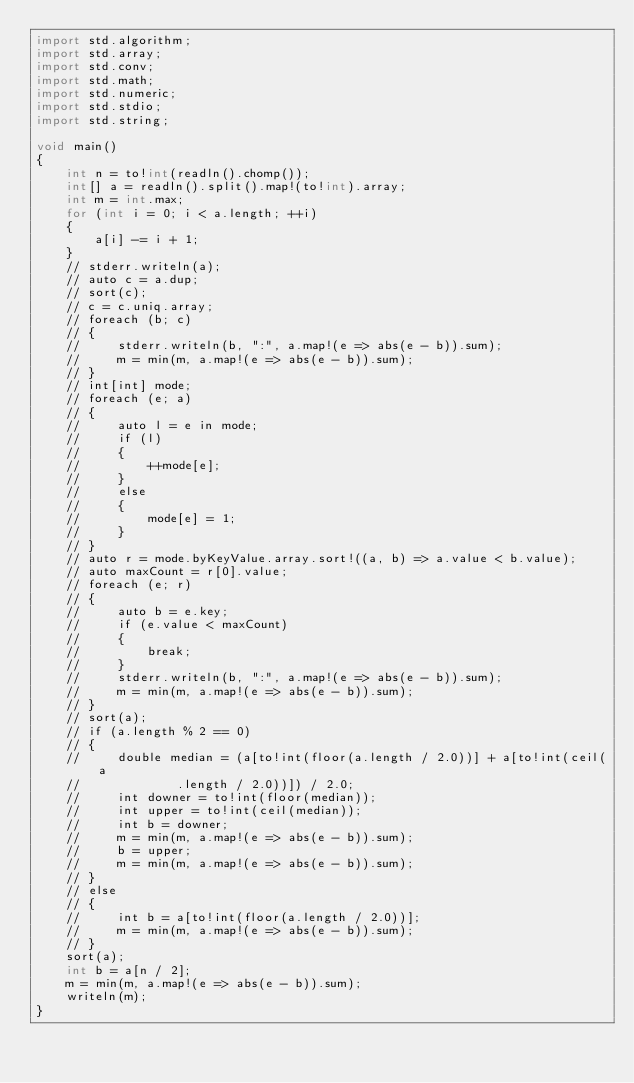<code> <loc_0><loc_0><loc_500><loc_500><_D_>import std.algorithm;
import std.array;
import std.conv;
import std.math;
import std.numeric;
import std.stdio;
import std.string;

void main()
{
    int n = to!int(readln().chomp());
    int[] a = readln().split().map!(to!int).array;
    int m = int.max;
    for (int i = 0; i < a.length; ++i)
    {
        a[i] -= i + 1;
    }
    // stderr.writeln(a);
    // auto c = a.dup;
    // sort(c);
    // c = c.uniq.array;
    // foreach (b; c)
    // {
    //     stderr.writeln(b, ":", a.map!(e => abs(e - b)).sum);
    //     m = min(m, a.map!(e => abs(e - b)).sum);
    // }
    // int[int] mode;
    // foreach (e; a)
    // {
    //     auto l = e in mode;
    //     if (l)
    //     {
    //         ++mode[e];
    //     }
    //     else
    //     {
    //         mode[e] = 1;
    //     }
    // }
    // auto r = mode.byKeyValue.array.sort!((a, b) => a.value < b.value);
    // auto maxCount = r[0].value;
    // foreach (e; r)
    // {
    //     auto b = e.key;
    //     if (e.value < maxCount)
    //     {
    //         break;
    //     }
    //     stderr.writeln(b, ":", a.map!(e => abs(e - b)).sum);
    //     m = min(m, a.map!(e => abs(e - b)).sum);
    // }
    // sort(a);
    // if (a.length % 2 == 0)
    // {
    //     double median = (a[to!int(floor(a.length / 2.0))] + a[to!int(ceil(a
    //             .length / 2.0))]) / 2.0;
    //     int downer = to!int(floor(median));
    //     int upper = to!int(ceil(median));
    //     int b = downer;
    //     m = min(m, a.map!(e => abs(e - b)).sum);
    //     b = upper;
    //     m = min(m, a.map!(e => abs(e - b)).sum);
    // }
    // else
    // {
    //     int b = a[to!int(floor(a.length / 2.0))];
    //     m = min(m, a.map!(e => abs(e - b)).sum);
    // }
    sort(a);
    int b = a[n / 2];
    m = min(m, a.map!(e => abs(e - b)).sum);
    writeln(m);
}
</code> 